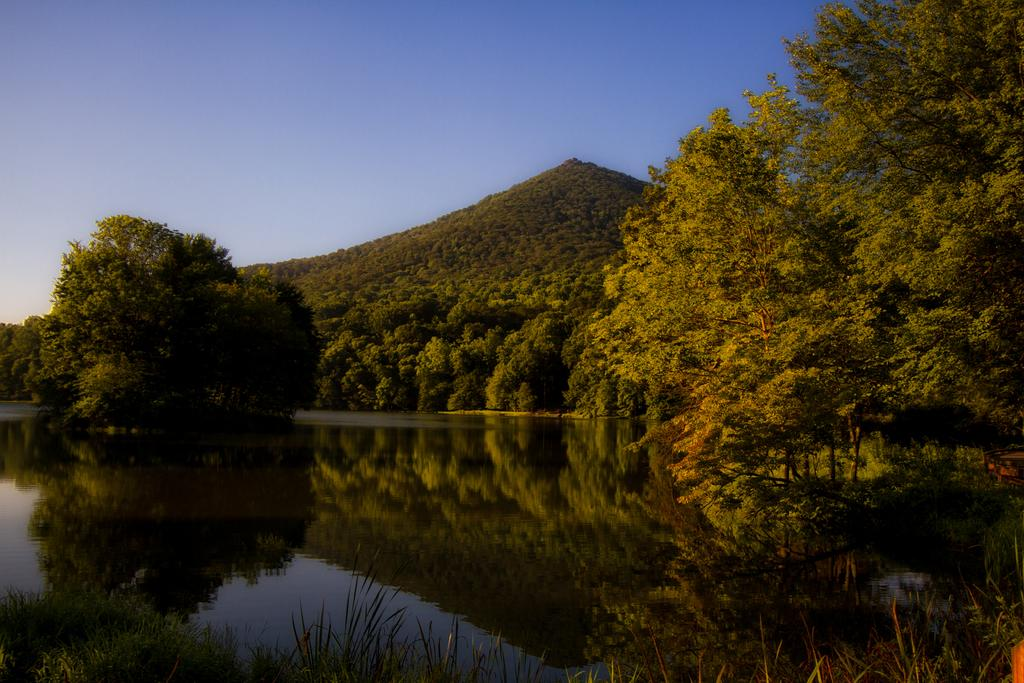What is located at the bottom of the image? There is a lake at the bottom of the image. What can be seen in the background of the image? There are trees in the background of the image. What is visible at the top of the image? The sky is visible at the top of the image. Where is the pipe located in the image? There is no pipe present in the image. What type of death can be seen in the image? There is no death depicted in the image; it features a lake, trees, and sky. 